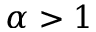<formula> <loc_0><loc_0><loc_500><loc_500>\alpha > 1</formula> 